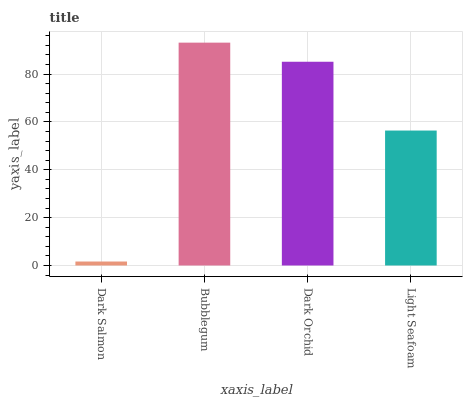Is Dark Salmon the minimum?
Answer yes or no. Yes. Is Bubblegum the maximum?
Answer yes or no. Yes. Is Dark Orchid the minimum?
Answer yes or no. No. Is Dark Orchid the maximum?
Answer yes or no. No. Is Bubblegum greater than Dark Orchid?
Answer yes or no. Yes. Is Dark Orchid less than Bubblegum?
Answer yes or no. Yes. Is Dark Orchid greater than Bubblegum?
Answer yes or no. No. Is Bubblegum less than Dark Orchid?
Answer yes or no. No. Is Dark Orchid the high median?
Answer yes or no. Yes. Is Light Seafoam the low median?
Answer yes or no. Yes. Is Bubblegum the high median?
Answer yes or no. No. Is Dark Salmon the low median?
Answer yes or no. No. 